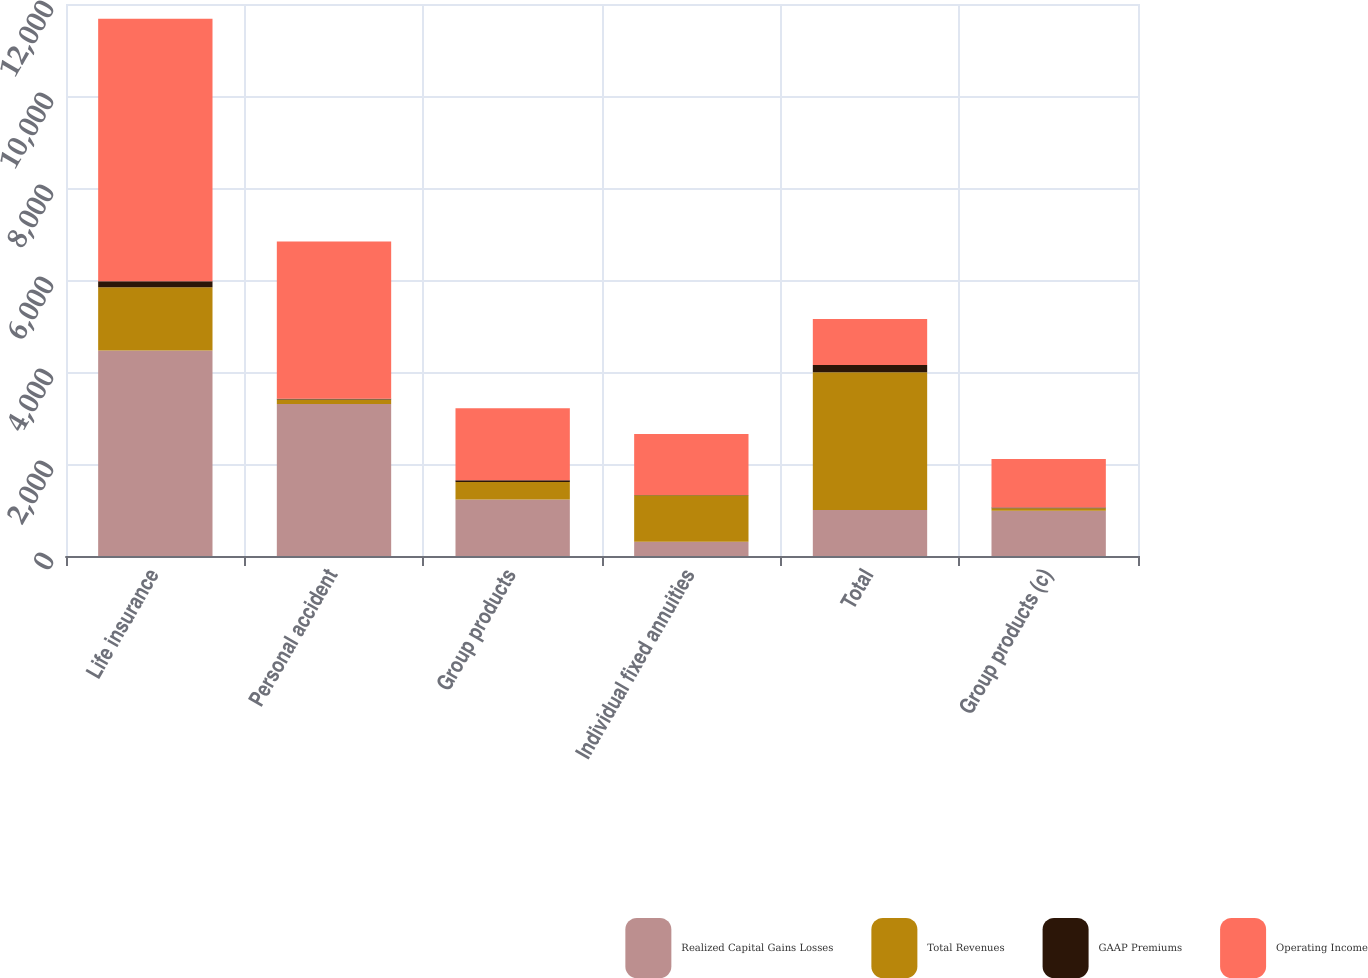Convert chart to OTSL. <chart><loc_0><loc_0><loc_500><loc_500><stacked_bar_chart><ecel><fcel>Life insurance<fcel>Personal accident<fcel>Group products<fcel>Individual fixed annuities<fcel>Total<fcel>Group products (c)<nl><fcel>Realized Capital Gains Losses<fcel>4469<fcel>3307<fcel>1229<fcel>312<fcel>998.5<fcel>986<nl><fcel>Total Revenues<fcel>1371<fcel>96<fcel>378<fcel>1011<fcel>2998<fcel>53<nl><fcel>GAAP Premiums<fcel>134<fcel>16<fcel>42<fcel>4<fcel>156<fcel>14<nl><fcel>Operating Income<fcel>5706<fcel>3419<fcel>1565<fcel>1327<fcel>998.5<fcel>1053<nl></chart> 